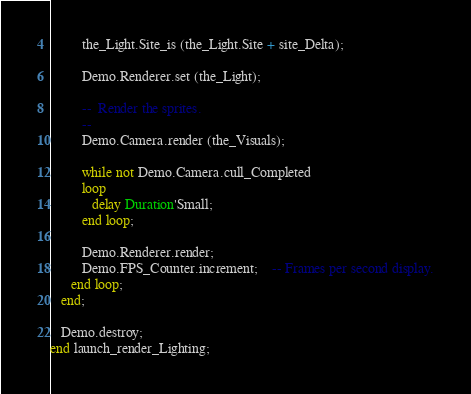Convert code to text. <code><loc_0><loc_0><loc_500><loc_500><_Ada_>
         the_Light.Site_is (the_Light.Site + site_Delta);

         Demo.Renderer.set (the_Light);

         --  Render the sprites.
         --
         Demo.Camera.render (the_Visuals);

         while not Demo.Camera.cull_Completed
         loop
            delay Duration'Small;
         end loop;

         Demo.Renderer.render;
         Demo.FPS_Counter.increment;    -- Frames per second display.
      end loop;
   end;

   Demo.destroy;
end launch_render_Lighting;
</code> 